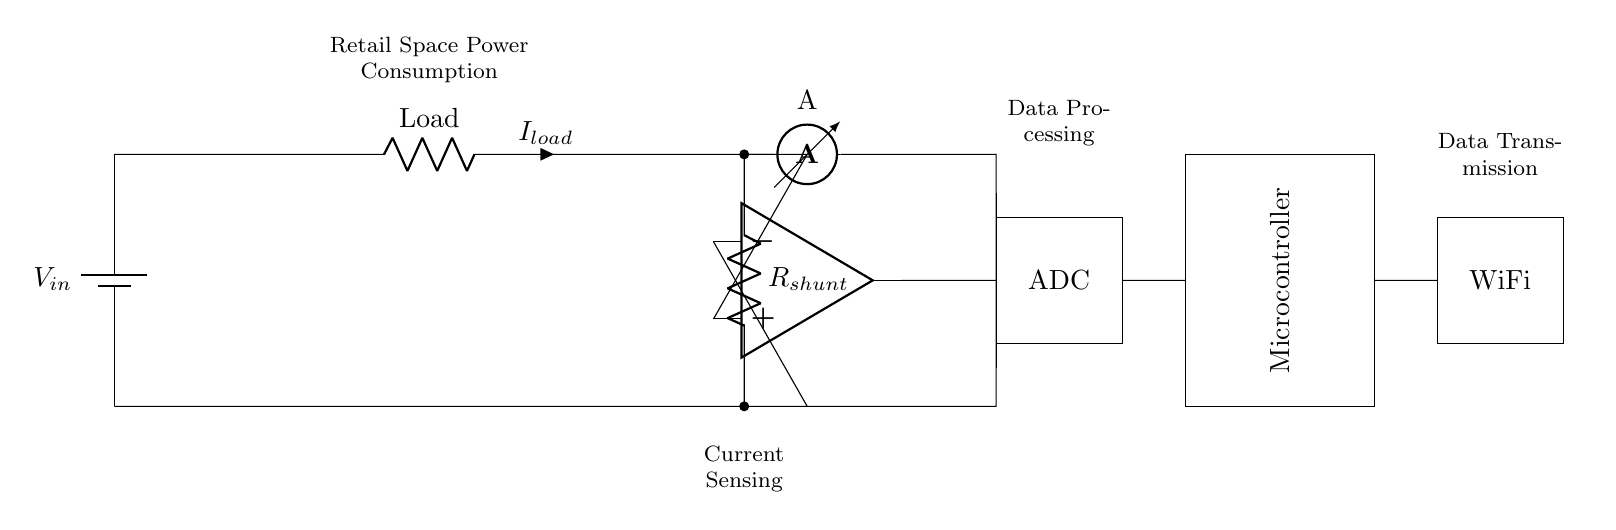What is the main function of the shunt resistor? The shunt resistor is used to measure the current flowing through the circuit by creating a small voltage drop proportional to the current, which can be detected by the differential amplifier.
Answer: Measure current What type of component is A in the diagram? A is an ammeter, which is used to measure the flow of current in the circuit. It is positioned to measure the current before it returns to the power source.
Answer: Ammeter How is data transmitted in this circuit? Data is transmitted via the WiFi module connected to the microcontroller, allowing for wireless communication of the current measurements.
Answer: WiFi What does the ADC do in this circuit? The ADC converts the analog voltage signal from the differential amplifier into a digital signal that can be processed by the microcontroller for analysis.
Answer: Convert to digital What type of amplifier is used in the circuit? The circuit uses a differential amplifier, which amplifies the difference between two input voltage signals. This is essential for accurately measuring the small voltage generated across the shunt resistor.
Answer: Differential What is the primary voltage source labeled in this circuit? The primary voltage source in the circuit is labeled as V sub in, which provides the necessary voltage for the entire circuit operation.
Answer: V in How does the microcontroller relate to the power consumption monitoring? The microcontroller processes the data received from the ADC to analyze power consumption and may control further actions or transmit data wirelessly, making it a crucial component in monitoring.
Answer: Data processing 